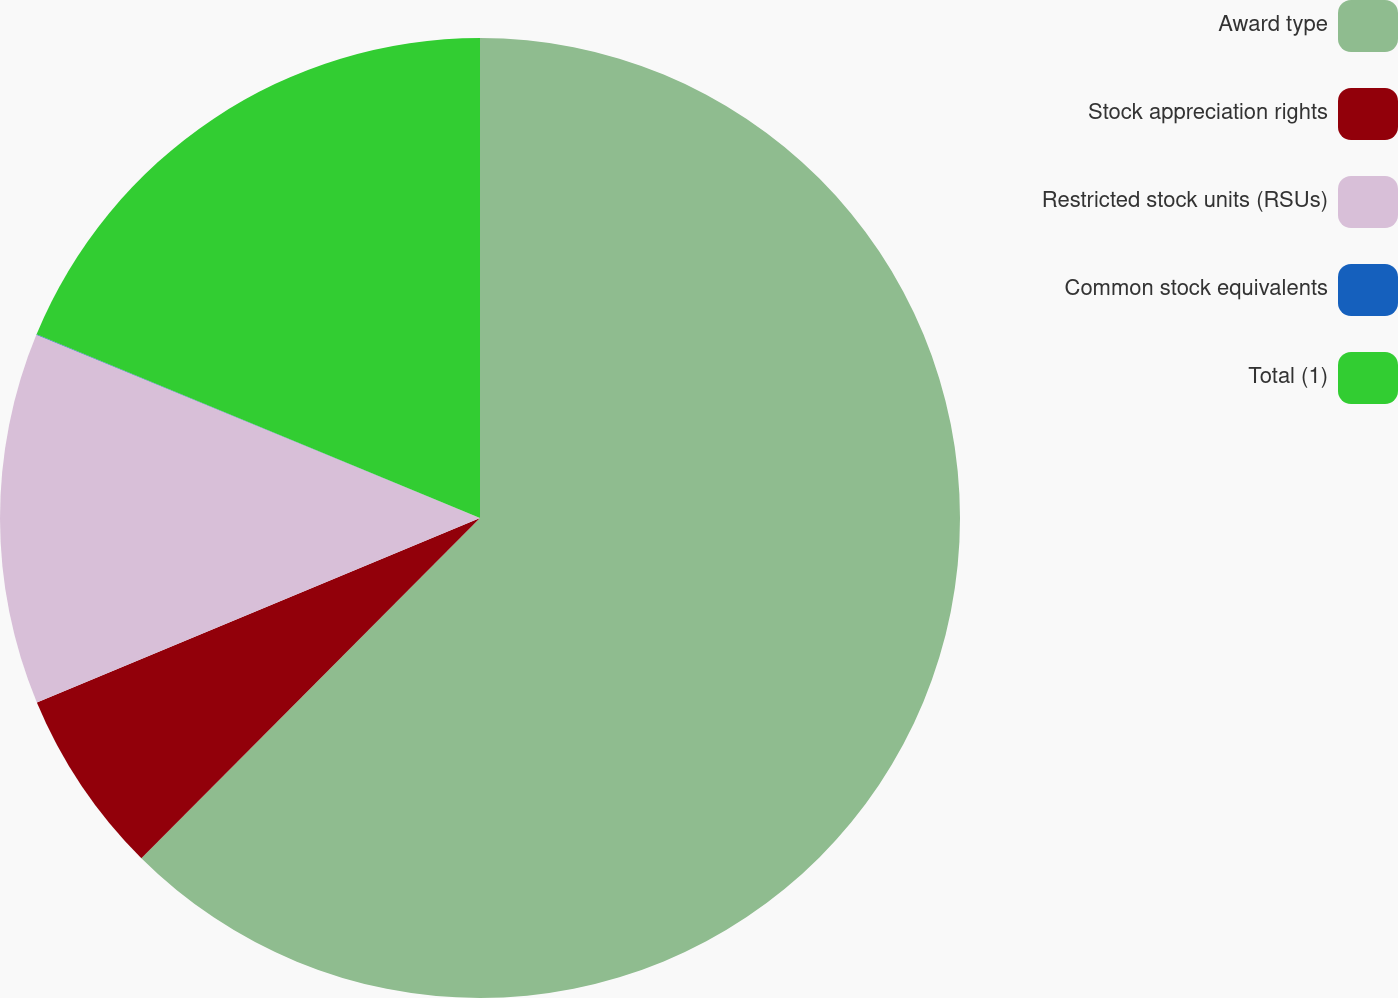Convert chart to OTSL. <chart><loc_0><loc_0><loc_500><loc_500><pie_chart><fcel>Award type<fcel>Stock appreciation rights<fcel>Restricted stock units (RSUs)<fcel>Common stock equivalents<fcel>Total (1)<nl><fcel>62.47%<fcel>6.26%<fcel>12.51%<fcel>0.02%<fcel>18.75%<nl></chart> 